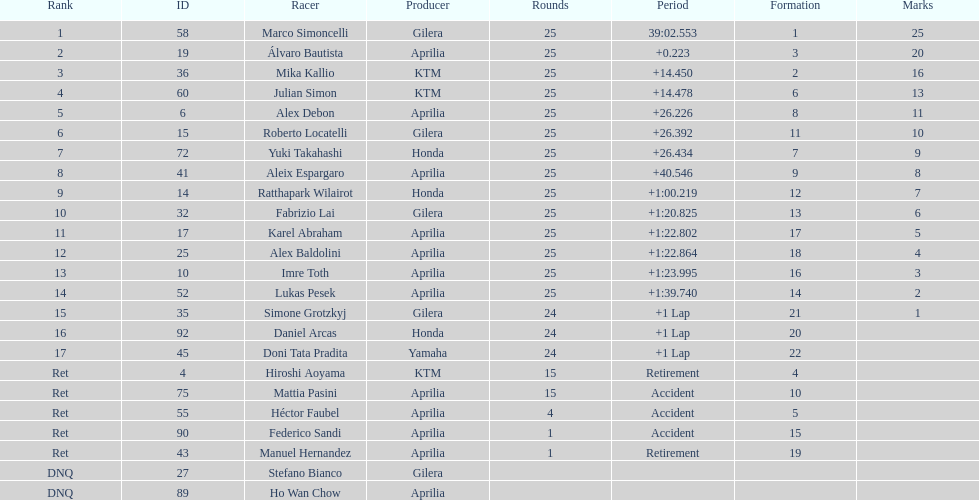Who is marco simoncelli's manufacturer Gilera. Would you mind parsing the complete table? {'header': ['Rank', 'ID', 'Racer', 'Producer', 'Rounds', 'Period', 'Formation', 'Marks'], 'rows': [['1', '58', 'Marco Simoncelli', 'Gilera', '25', '39:02.553', '1', '25'], ['2', '19', 'Álvaro Bautista', 'Aprilia', '25', '+0.223', '3', '20'], ['3', '36', 'Mika Kallio', 'KTM', '25', '+14.450', '2', '16'], ['4', '60', 'Julian Simon', 'KTM', '25', '+14.478', '6', '13'], ['5', '6', 'Alex Debon', 'Aprilia', '25', '+26.226', '8', '11'], ['6', '15', 'Roberto Locatelli', 'Gilera', '25', '+26.392', '11', '10'], ['7', '72', 'Yuki Takahashi', 'Honda', '25', '+26.434', '7', '9'], ['8', '41', 'Aleix Espargaro', 'Aprilia', '25', '+40.546', '9', '8'], ['9', '14', 'Ratthapark Wilairot', 'Honda', '25', '+1:00.219', '12', '7'], ['10', '32', 'Fabrizio Lai', 'Gilera', '25', '+1:20.825', '13', '6'], ['11', '17', 'Karel Abraham', 'Aprilia', '25', '+1:22.802', '17', '5'], ['12', '25', 'Alex Baldolini', 'Aprilia', '25', '+1:22.864', '18', '4'], ['13', '10', 'Imre Toth', 'Aprilia', '25', '+1:23.995', '16', '3'], ['14', '52', 'Lukas Pesek', 'Aprilia', '25', '+1:39.740', '14', '2'], ['15', '35', 'Simone Grotzkyj', 'Gilera', '24', '+1 Lap', '21', '1'], ['16', '92', 'Daniel Arcas', 'Honda', '24', '+1 Lap', '20', ''], ['17', '45', 'Doni Tata Pradita', 'Yamaha', '24', '+1 Lap', '22', ''], ['Ret', '4', 'Hiroshi Aoyama', 'KTM', '15', 'Retirement', '4', ''], ['Ret', '75', 'Mattia Pasini', 'Aprilia', '15', 'Accident', '10', ''], ['Ret', '55', 'Héctor Faubel', 'Aprilia', '4', 'Accident', '5', ''], ['Ret', '90', 'Federico Sandi', 'Aprilia', '1', 'Accident', '15', ''], ['Ret', '43', 'Manuel Hernandez', 'Aprilia', '1', 'Retirement', '19', ''], ['DNQ', '27', 'Stefano Bianco', 'Gilera', '', '', '', ''], ['DNQ', '89', 'Ho Wan Chow', 'Aprilia', '', '', '', '']]} 